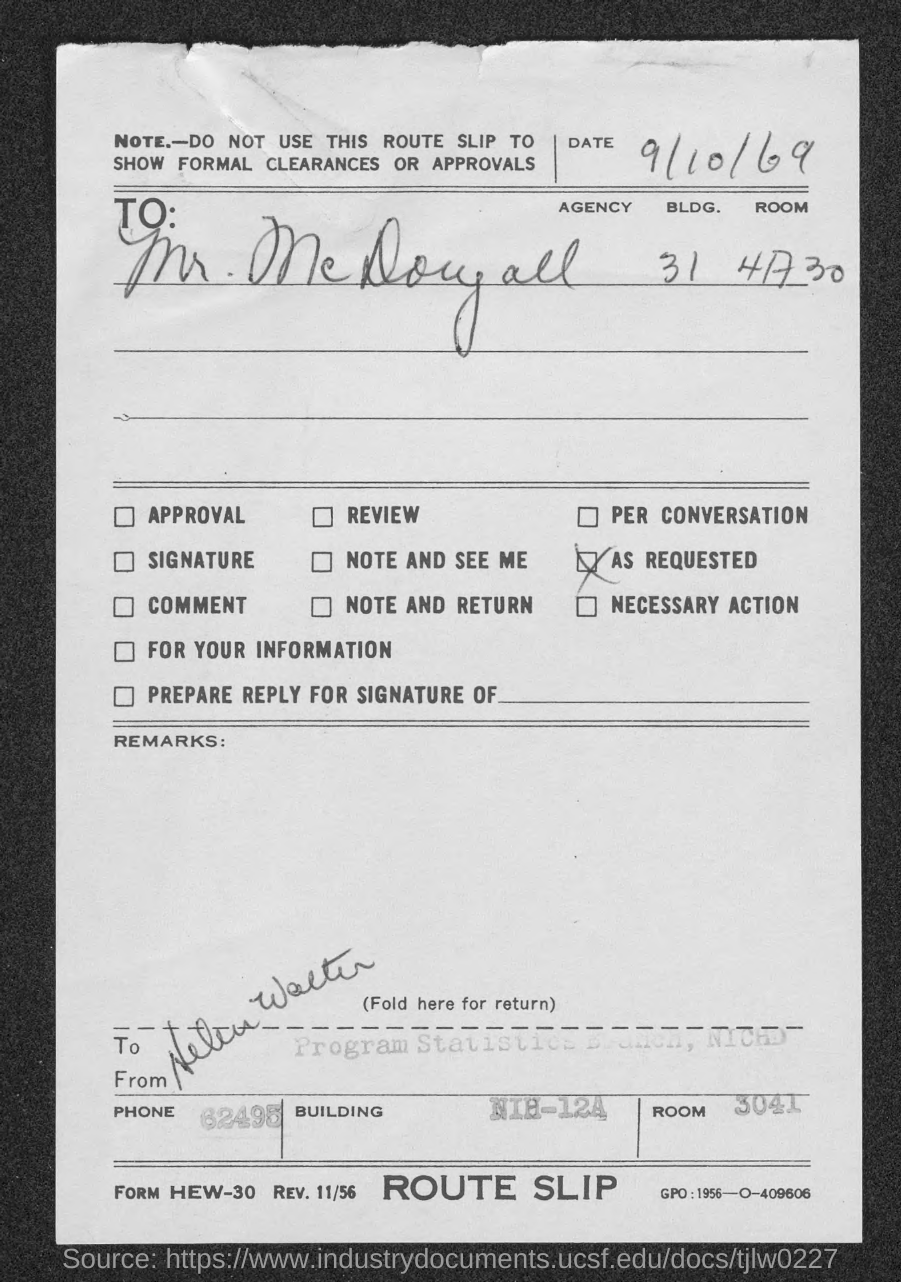What is the Date?
Your answer should be very brief. 9/10/69. To Whom is this letter addressed to?
Your answer should be compact. Mr. McDougall. What is the Phone?
Ensure brevity in your answer.  62495. What is the Room No.?
Offer a terse response. 3041. 